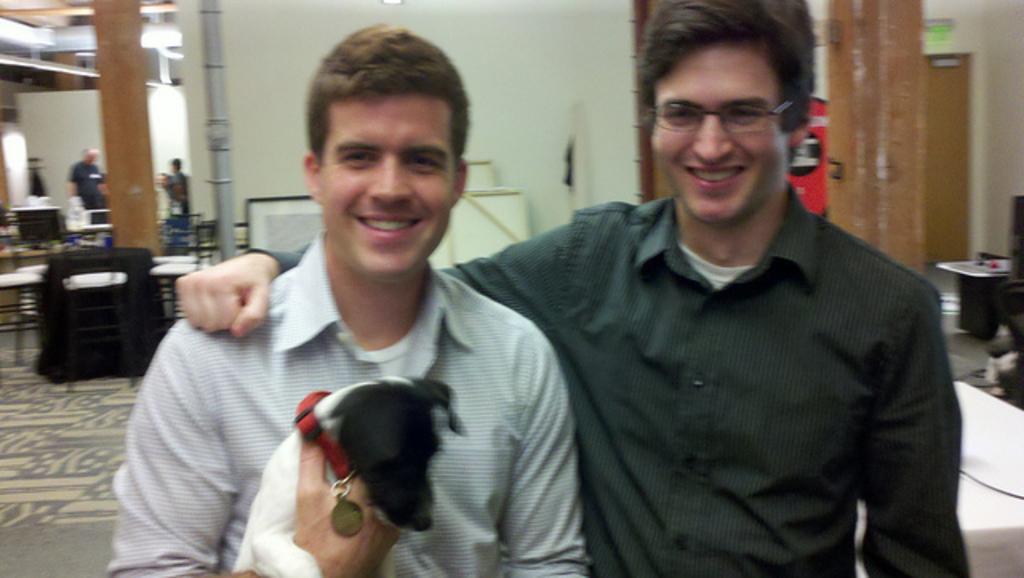Can you describe this image briefly? The four persons are standing. On the right side of the persons are smiling. one person is wearing spectacle. Another person is holding a dog. We can see in the background wall,board,table,pillar. 